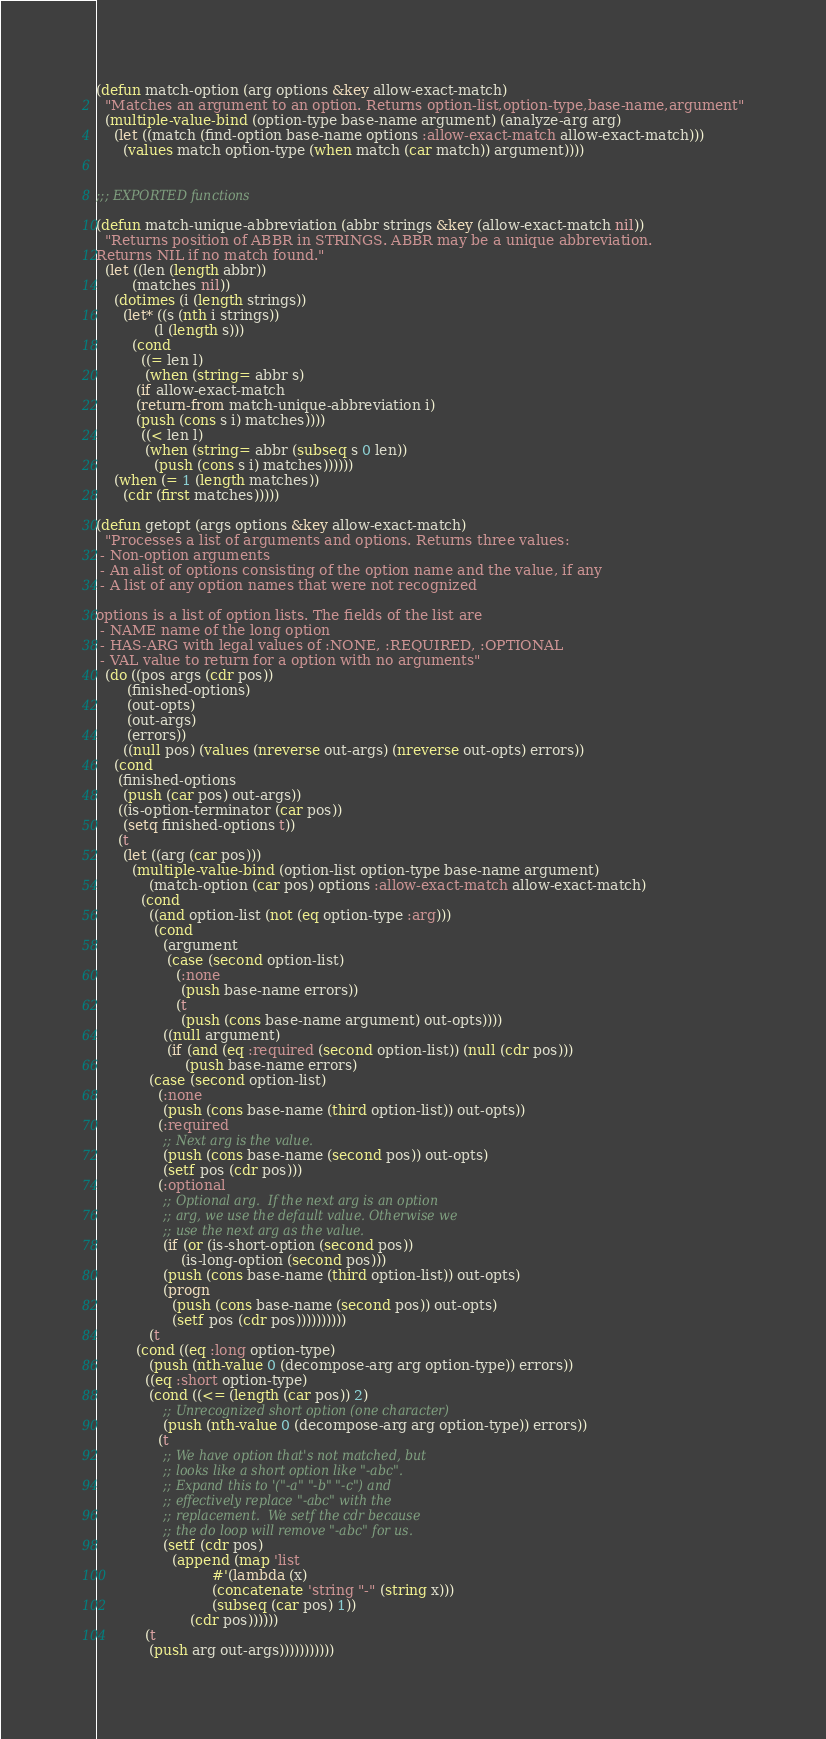<code> <loc_0><loc_0><loc_500><loc_500><_Lisp_>(defun match-option (arg options &key allow-exact-match)
  "Matches an argument to an option. Returns option-list,option-type,base-name,argument"
  (multiple-value-bind (option-type base-name argument) (analyze-arg arg)
    (let ((match (find-option base-name options :allow-exact-match allow-exact-match)))
      (values match option-type (when match (car match)) argument))))


;;; EXPORTED functions

(defun match-unique-abbreviation (abbr strings &key (allow-exact-match nil))
  "Returns position of ABBR in STRINGS. ABBR may be a unique abbreviation.
Returns NIL if no match found."
  (let ((len (length abbr))
        (matches nil))
    (dotimes (i (length strings))
      (let* ((s (nth i strings))
             (l (length s)))
        (cond
          ((= len l)
           (when (string= abbr s)
	     (if allow-exact-match
		 (return-from match-unique-abbreviation i)
		 (push (cons s i) matches))))
          ((< len l)
           (when (string= abbr (subseq s 0 len))
             (push (cons s i) matches))))))
    (when (= 1 (length matches))
      (cdr (first matches)))))

(defun getopt (args options &key allow-exact-match)
  "Processes a list of arguments and options. Returns three values:
 - Non-option arguments
 - An alist of options consisting of the option name and the value, if any
 - A list of any option names that were not recognized

options is a list of option lists. The fields of the list are
 - NAME name of the long option
 - HAS-ARG with legal values of :NONE, :REQUIRED, :OPTIONAL
 - VAL value to return for a option with no arguments"
  (do ((pos args (cdr pos))
       (finished-options)
       (out-opts)
       (out-args)
       (errors))
      ((null pos) (values (nreverse out-args) (nreverse out-opts) errors))
    (cond
     (finished-options
      (push (car pos) out-args))
     ((is-option-terminator (car pos))
      (setq finished-options t))
     (t
      (let ((arg (car pos)))
        (multiple-value-bind (option-list option-type base-name argument)
            (match-option (car pos) options :allow-exact-match allow-exact-match)
          (cond
            ((and option-list (not (eq option-type :arg)))
             (cond
               (argument
                (case (second option-list)
                  (:none
                   (push base-name errors))
                  (t
                   (push (cons base-name argument) out-opts))))
               ((null argument)
                (if (and (eq :required (second option-list)) (null (cdr pos)))
                    (push base-name errors)
		    (case (second option-list)
		      (:none
		       (push (cons base-name (third option-list)) out-opts))
		      (:required
		       ;; Next arg is the value.  
		       (push (cons base-name (second pos)) out-opts)
		       (setf pos (cdr pos)))
		      (:optional
		       ;; Optional arg.  If the next arg is an option
		       ;; arg, we use the default value. Otherwise we
		       ;; use the next arg as the value.
		       (if (or (is-short-option (second pos))
			       (is-long-option (second pos)))
			   (push (cons base-name (third option-list)) out-opts)
			   (progn
			     (push (cons base-name (second pos)) out-opts)
			     (setf pos (cdr pos))))))))))
            (t
	     (cond ((eq :long option-type)
		    (push (nth-value 0 (decompose-arg arg option-type)) errors))
		   ((eq :short option-type)
		    (cond ((<= (length (car pos)) 2)
			   ;; Unrecognized short option (one character)
			   (push (nth-value 0 (decompose-arg arg option-type)) errors))
			  (t
			   ;; We have option that's not matched, but
			   ;; looks like a short option like "-abc".
			   ;; Expand this to '("-a" "-b" "-c") and
			   ;; effectively replace "-abc" with the
			   ;; replacement.  We setf the cdr because
			   ;; the do loop will remove "-abc" for us.
			   (setf (cdr pos)
				 (append (map 'list
					      #'(lambda (x)
						  (concatenate 'string "-" (string x)))
					      (subseq (car pos) 1))
					 (cdr pos))))))
		   (t
		    (push arg out-args)))))))))))

</code> 